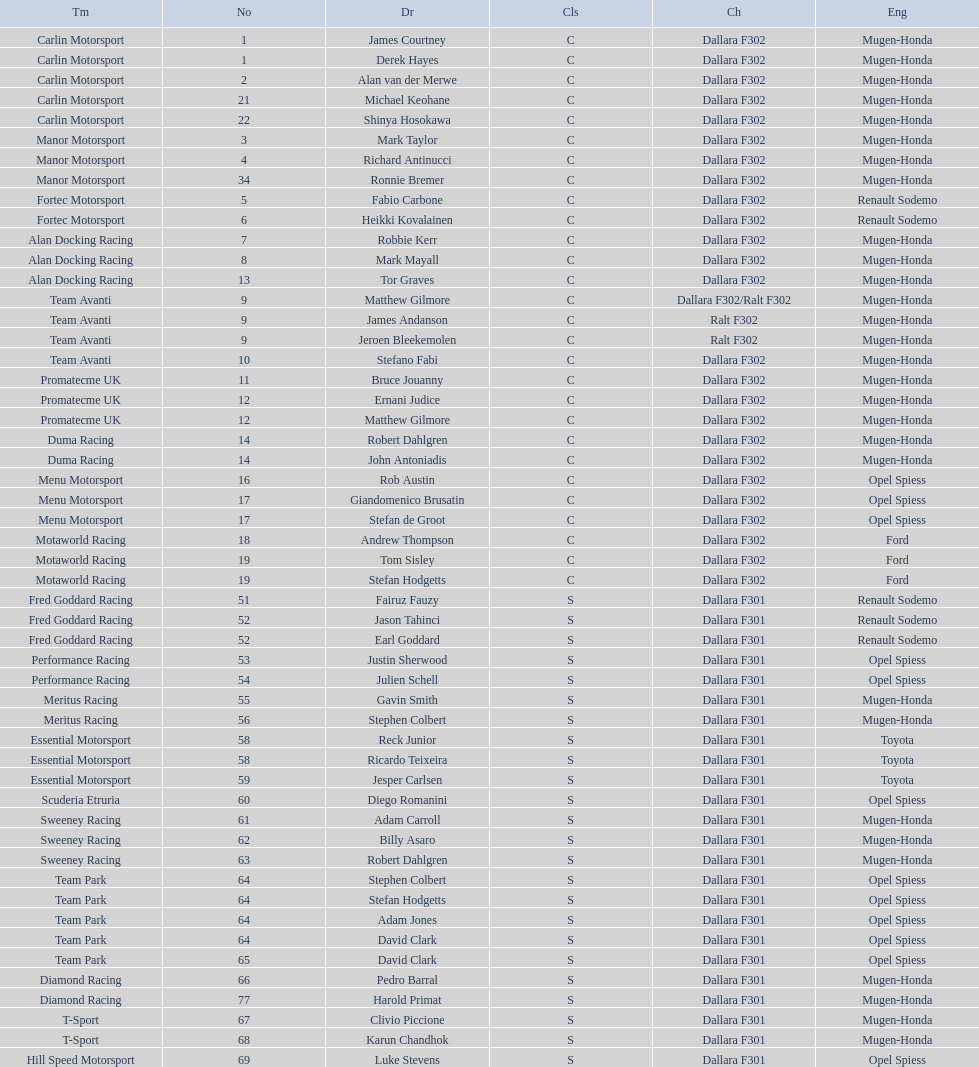Who had more drivers, team avanti or motaworld racing? Team Avanti. 